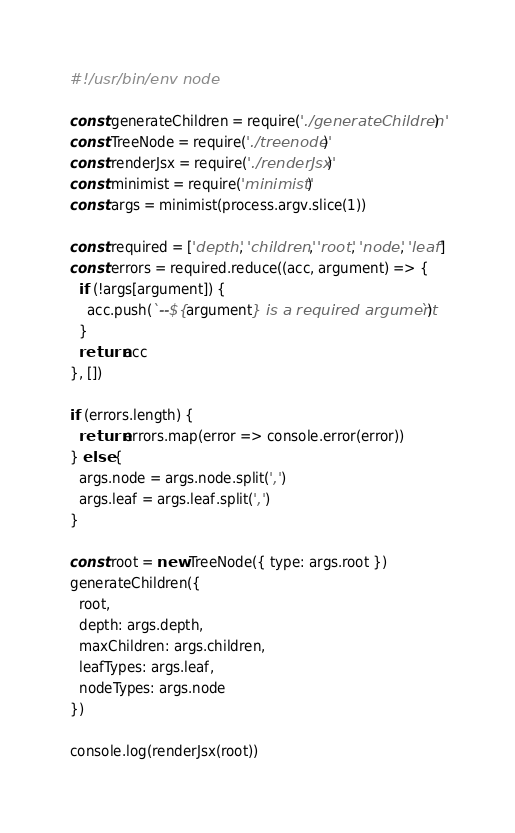<code> <loc_0><loc_0><loc_500><loc_500><_JavaScript_>#!/usr/bin/env node

const generateChildren = require('./generateChildren')
const TreeNode = require('./treenode')
const renderJsx = require('./renderJsx')
const minimist = require('minimist')
const args = minimist(process.argv.slice(1))

const required = ['depth', 'children', 'root', 'node', 'leaf']
const errors = required.reduce((acc, argument) => {
  if (!args[argument]) {
    acc.push(`--${argument} is a required argument`)
  }
  return acc
}, [])

if (errors.length) {
  return errors.map(error => console.error(error))
} else {
  args.node = args.node.split(',')
  args.leaf = args.leaf.split(',')
}

const root = new TreeNode({ type: args.root })
generateChildren({
  root,
  depth: args.depth,
  maxChildren: args.children,
  leafTypes: args.leaf,
  nodeTypes: args.node
})

console.log(renderJsx(root))
</code> 